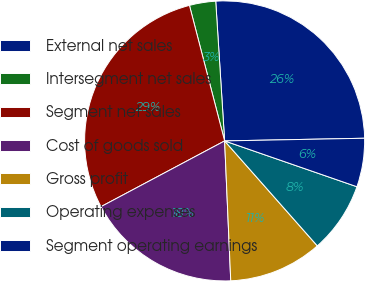<chart> <loc_0><loc_0><loc_500><loc_500><pie_chart><fcel>External net sales<fcel>Intersegment net sales<fcel>Segment net sales<fcel>Cost of goods sold<fcel>Gross profit<fcel>Operating expenses<fcel>Segment operating earnings<nl><fcel>25.71%<fcel>3.03%<fcel>28.74%<fcel>17.92%<fcel>10.82%<fcel>8.18%<fcel>5.61%<nl></chart> 